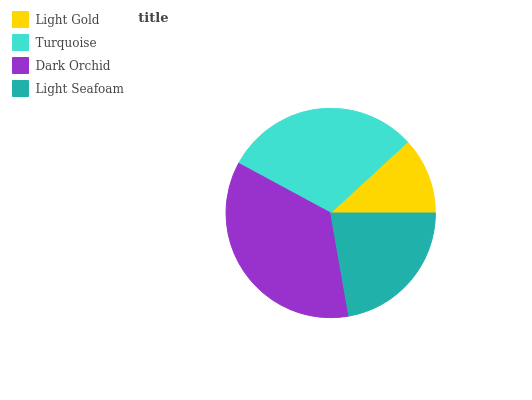Is Light Gold the minimum?
Answer yes or no. Yes. Is Dark Orchid the maximum?
Answer yes or no. Yes. Is Turquoise the minimum?
Answer yes or no. No. Is Turquoise the maximum?
Answer yes or no. No. Is Turquoise greater than Light Gold?
Answer yes or no. Yes. Is Light Gold less than Turquoise?
Answer yes or no. Yes. Is Light Gold greater than Turquoise?
Answer yes or no. No. Is Turquoise less than Light Gold?
Answer yes or no. No. Is Turquoise the high median?
Answer yes or no. Yes. Is Light Seafoam the low median?
Answer yes or no. Yes. Is Light Gold the high median?
Answer yes or no. No. Is Light Gold the low median?
Answer yes or no. No. 